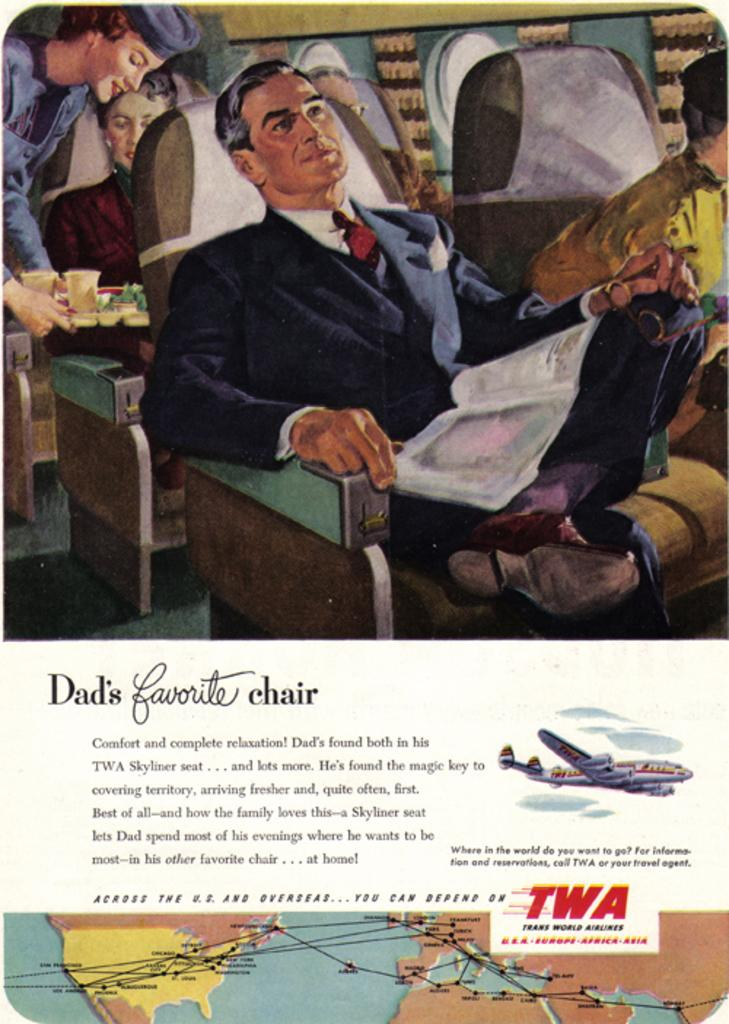What is present in the image that contains both images and text? There is a poster in the image that contains images and text. How many cows are depicted on the poster in the image? There is no information about cows in the provided facts, so we cannot determine if any cows are depicted on the poster. 